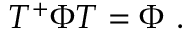<formula> <loc_0><loc_0><loc_500><loc_500>T ^ { + } \Phi T = \Phi \ .</formula> 